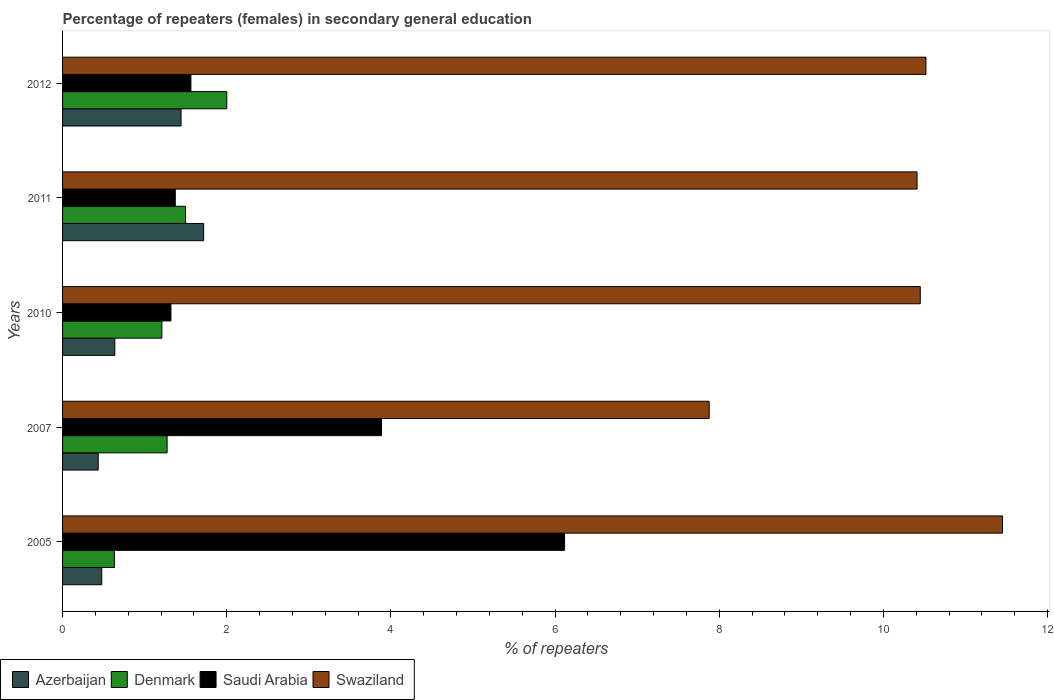How many different coloured bars are there?
Provide a short and direct response. 4. How many groups of bars are there?
Keep it short and to the point. 5. Are the number of bars on each tick of the Y-axis equal?
Ensure brevity in your answer.  Yes. How many bars are there on the 4th tick from the bottom?
Give a very brief answer. 4. In how many cases, is the number of bars for a given year not equal to the number of legend labels?
Provide a short and direct response. 0. What is the percentage of female repeaters in Swaziland in 2007?
Your answer should be compact. 7.88. Across all years, what is the maximum percentage of female repeaters in Saudi Arabia?
Ensure brevity in your answer.  6.12. Across all years, what is the minimum percentage of female repeaters in Saudi Arabia?
Keep it short and to the point. 1.32. In which year was the percentage of female repeaters in Azerbaijan maximum?
Your answer should be compact. 2011. What is the total percentage of female repeaters in Swaziland in the graph?
Offer a very short reply. 50.7. What is the difference between the percentage of female repeaters in Denmark in 2010 and that in 2011?
Give a very brief answer. -0.29. What is the difference between the percentage of female repeaters in Denmark in 2011 and the percentage of female repeaters in Swaziland in 2012?
Your answer should be very brief. -9.02. What is the average percentage of female repeaters in Denmark per year?
Offer a terse response. 1.32. In the year 2012, what is the difference between the percentage of female repeaters in Swaziland and percentage of female repeaters in Azerbaijan?
Offer a terse response. 9.07. What is the ratio of the percentage of female repeaters in Denmark in 2007 to that in 2011?
Provide a succinct answer. 0.85. Is the difference between the percentage of female repeaters in Swaziland in 2010 and 2011 greater than the difference between the percentage of female repeaters in Azerbaijan in 2010 and 2011?
Ensure brevity in your answer.  Yes. What is the difference between the highest and the second highest percentage of female repeaters in Azerbaijan?
Provide a short and direct response. 0.28. What is the difference between the highest and the lowest percentage of female repeaters in Swaziland?
Your answer should be very brief. 3.57. In how many years, is the percentage of female repeaters in Azerbaijan greater than the average percentage of female repeaters in Azerbaijan taken over all years?
Your response must be concise. 2. Is the sum of the percentage of female repeaters in Azerbaijan in 2005 and 2007 greater than the maximum percentage of female repeaters in Swaziland across all years?
Ensure brevity in your answer.  No. What does the 4th bar from the top in 2011 represents?
Provide a short and direct response. Azerbaijan. Are all the bars in the graph horizontal?
Make the answer very short. Yes. How many years are there in the graph?
Provide a short and direct response. 5. Does the graph contain any zero values?
Ensure brevity in your answer.  No. Does the graph contain grids?
Give a very brief answer. No. Where does the legend appear in the graph?
Your answer should be very brief. Bottom left. How many legend labels are there?
Keep it short and to the point. 4. What is the title of the graph?
Ensure brevity in your answer.  Percentage of repeaters (females) in secondary general education. Does "Yemen, Rep." appear as one of the legend labels in the graph?
Provide a succinct answer. No. What is the label or title of the X-axis?
Give a very brief answer. % of repeaters. What is the label or title of the Y-axis?
Make the answer very short. Years. What is the % of repeaters of Azerbaijan in 2005?
Your answer should be compact. 0.48. What is the % of repeaters in Denmark in 2005?
Ensure brevity in your answer.  0.63. What is the % of repeaters in Saudi Arabia in 2005?
Keep it short and to the point. 6.12. What is the % of repeaters in Swaziland in 2005?
Provide a short and direct response. 11.45. What is the % of repeaters in Azerbaijan in 2007?
Offer a terse response. 0.43. What is the % of repeaters in Denmark in 2007?
Ensure brevity in your answer.  1.27. What is the % of repeaters of Saudi Arabia in 2007?
Your answer should be compact. 3.89. What is the % of repeaters of Swaziland in 2007?
Your answer should be compact. 7.88. What is the % of repeaters of Azerbaijan in 2010?
Your response must be concise. 0.64. What is the % of repeaters of Denmark in 2010?
Ensure brevity in your answer.  1.21. What is the % of repeaters of Saudi Arabia in 2010?
Keep it short and to the point. 1.32. What is the % of repeaters of Swaziland in 2010?
Your response must be concise. 10.45. What is the % of repeaters in Azerbaijan in 2011?
Give a very brief answer. 1.72. What is the % of repeaters of Denmark in 2011?
Your answer should be very brief. 1.5. What is the % of repeaters of Saudi Arabia in 2011?
Give a very brief answer. 1.37. What is the % of repeaters of Swaziland in 2011?
Offer a very short reply. 10.41. What is the % of repeaters in Azerbaijan in 2012?
Your response must be concise. 1.44. What is the % of repeaters of Denmark in 2012?
Ensure brevity in your answer.  2. What is the % of repeaters in Saudi Arabia in 2012?
Provide a succinct answer. 1.56. What is the % of repeaters of Swaziland in 2012?
Offer a very short reply. 10.52. Across all years, what is the maximum % of repeaters in Azerbaijan?
Give a very brief answer. 1.72. Across all years, what is the maximum % of repeaters in Denmark?
Ensure brevity in your answer.  2. Across all years, what is the maximum % of repeaters in Saudi Arabia?
Ensure brevity in your answer.  6.12. Across all years, what is the maximum % of repeaters in Swaziland?
Ensure brevity in your answer.  11.45. Across all years, what is the minimum % of repeaters of Azerbaijan?
Give a very brief answer. 0.43. Across all years, what is the minimum % of repeaters of Denmark?
Your answer should be compact. 0.63. Across all years, what is the minimum % of repeaters in Saudi Arabia?
Provide a short and direct response. 1.32. Across all years, what is the minimum % of repeaters in Swaziland?
Ensure brevity in your answer.  7.88. What is the total % of repeaters of Azerbaijan in the graph?
Your response must be concise. 4.71. What is the total % of repeaters of Denmark in the graph?
Provide a succinct answer. 6.61. What is the total % of repeaters in Saudi Arabia in the graph?
Your answer should be very brief. 14.26. What is the total % of repeaters of Swaziland in the graph?
Provide a short and direct response. 50.7. What is the difference between the % of repeaters in Azerbaijan in 2005 and that in 2007?
Provide a short and direct response. 0.04. What is the difference between the % of repeaters in Denmark in 2005 and that in 2007?
Provide a succinct answer. -0.64. What is the difference between the % of repeaters of Saudi Arabia in 2005 and that in 2007?
Keep it short and to the point. 2.23. What is the difference between the % of repeaters of Swaziland in 2005 and that in 2007?
Provide a short and direct response. 3.57. What is the difference between the % of repeaters in Azerbaijan in 2005 and that in 2010?
Offer a terse response. -0.16. What is the difference between the % of repeaters in Denmark in 2005 and that in 2010?
Keep it short and to the point. -0.58. What is the difference between the % of repeaters of Saudi Arabia in 2005 and that in 2010?
Provide a short and direct response. 4.8. What is the difference between the % of repeaters of Swaziland in 2005 and that in 2010?
Give a very brief answer. 1. What is the difference between the % of repeaters of Azerbaijan in 2005 and that in 2011?
Ensure brevity in your answer.  -1.24. What is the difference between the % of repeaters in Denmark in 2005 and that in 2011?
Provide a short and direct response. -0.87. What is the difference between the % of repeaters of Saudi Arabia in 2005 and that in 2011?
Your response must be concise. 4.74. What is the difference between the % of repeaters of Swaziland in 2005 and that in 2011?
Keep it short and to the point. 1.04. What is the difference between the % of repeaters in Azerbaijan in 2005 and that in 2012?
Keep it short and to the point. -0.97. What is the difference between the % of repeaters of Denmark in 2005 and that in 2012?
Give a very brief answer. -1.37. What is the difference between the % of repeaters of Saudi Arabia in 2005 and that in 2012?
Your response must be concise. 4.55. What is the difference between the % of repeaters of Swaziland in 2005 and that in 2012?
Your answer should be very brief. 0.93. What is the difference between the % of repeaters in Azerbaijan in 2007 and that in 2010?
Give a very brief answer. -0.2. What is the difference between the % of repeaters in Denmark in 2007 and that in 2010?
Your response must be concise. 0.06. What is the difference between the % of repeaters in Saudi Arabia in 2007 and that in 2010?
Your response must be concise. 2.57. What is the difference between the % of repeaters in Swaziland in 2007 and that in 2010?
Your answer should be compact. -2.57. What is the difference between the % of repeaters in Azerbaijan in 2007 and that in 2011?
Keep it short and to the point. -1.28. What is the difference between the % of repeaters of Denmark in 2007 and that in 2011?
Make the answer very short. -0.22. What is the difference between the % of repeaters in Saudi Arabia in 2007 and that in 2011?
Provide a short and direct response. 2.51. What is the difference between the % of repeaters in Swaziland in 2007 and that in 2011?
Your answer should be very brief. -2.53. What is the difference between the % of repeaters of Azerbaijan in 2007 and that in 2012?
Offer a terse response. -1.01. What is the difference between the % of repeaters of Denmark in 2007 and that in 2012?
Keep it short and to the point. -0.73. What is the difference between the % of repeaters in Saudi Arabia in 2007 and that in 2012?
Offer a terse response. 2.32. What is the difference between the % of repeaters in Swaziland in 2007 and that in 2012?
Give a very brief answer. -2.64. What is the difference between the % of repeaters of Azerbaijan in 2010 and that in 2011?
Provide a succinct answer. -1.08. What is the difference between the % of repeaters in Denmark in 2010 and that in 2011?
Ensure brevity in your answer.  -0.29. What is the difference between the % of repeaters of Saudi Arabia in 2010 and that in 2011?
Give a very brief answer. -0.05. What is the difference between the % of repeaters in Swaziland in 2010 and that in 2011?
Make the answer very short. 0.04. What is the difference between the % of repeaters in Azerbaijan in 2010 and that in 2012?
Keep it short and to the point. -0.81. What is the difference between the % of repeaters in Denmark in 2010 and that in 2012?
Your answer should be compact. -0.79. What is the difference between the % of repeaters of Saudi Arabia in 2010 and that in 2012?
Your answer should be very brief. -0.24. What is the difference between the % of repeaters in Swaziland in 2010 and that in 2012?
Ensure brevity in your answer.  -0.07. What is the difference between the % of repeaters of Azerbaijan in 2011 and that in 2012?
Provide a succinct answer. 0.28. What is the difference between the % of repeaters in Denmark in 2011 and that in 2012?
Your answer should be very brief. -0.5. What is the difference between the % of repeaters of Saudi Arabia in 2011 and that in 2012?
Keep it short and to the point. -0.19. What is the difference between the % of repeaters of Swaziland in 2011 and that in 2012?
Make the answer very short. -0.11. What is the difference between the % of repeaters of Azerbaijan in 2005 and the % of repeaters of Denmark in 2007?
Provide a short and direct response. -0.8. What is the difference between the % of repeaters of Azerbaijan in 2005 and the % of repeaters of Saudi Arabia in 2007?
Keep it short and to the point. -3.41. What is the difference between the % of repeaters in Azerbaijan in 2005 and the % of repeaters in Swaziland in 2007?
Provide a short and direct response. -7.4. What is the difference between the % of repeaters of Denmark in 2005 and the % of repeaters of Saudi Arabia in 2007?
Offer a very short reply. -3.25. What is the difference between the % of repeaters in Denmark in 2005 and the % of repeaters in Swaziland in 2007?
Keep it short and to the point. -7.25. What is the difference between the % of repeaters in Saudi Arabia in 2005 and the % of repeaters in Swaziland in 2007?
Offer a very short reply. -1.76. What is the difference between the % of repeaters of Azerbaijan in 2005 and the % of repeaters of Denmark in 2010?
Provide a succinct answer. -0.73. What is the difference between the % of repeaters of Azerbaijan in 2005 and the % of repeaters of Saudi Arabia in 2010?
Offer a very short reply. -0.84. What is the difference between the % of repeaters in Azerbaijan in 2005 and the % of repeaters in Swaziland in 2010?
Keep it short and to the point. -9.97. What is the difference between the % of repeaters in Denmark in 2005 and the % of repeaters in Saudi Arabia in 2010?
Your answer should be very brief. -0.69. What is the difference between the % of repeaters in Denmark in 2005 and the % of repeaters in Swaziland in 2010?
Offer a very short reply. -9.82. What is the difference between the % of repeaters of Saudi Arabia in 2005 and the % of repeaters of Swaziland in 2010?
Give a very brief answer. -4.33. What is the difference between the % of repeaters of Azerbaijan in 2005 and the % of repeaters of Denmark in 2011?
Ensure brevity in your answer.  -1.02. What is the difference between the % of repeaters in Azerbaijan in 2005 and the % of repeaters in Saudi Arabia in 2011?
Offer a very short reply. -0.9. What is the difference between the % of repeaters in Azerbaijan in 2005 and the % of repeaters in Swaziland in 2011?
Make the answer very short. -9.93. What is the difference between the % of repeaters of Denmark in 2005 and the % of repeaters of Saudi Arabia in 2011?
Your response must be concise. -0.74. What is the difference between the % of repeaters of Denmark in 2005 and the % of repeaters of Swaziland in 2011?
Make the answer very short. -9.78. What is the difference between the % of repeaters of Saudi Arabia in 2005 and the % of repeaters of Swaziland in 2011?
Provide a succinct answer. -4.29. What is the difference between the % of repeaters of Azerbaijan in 2005 and the % of repeaters of Denmark in 2012?
Your answer should be compact. -1.52. What is the difference between the % of repeaters of Azerbaijan in 2005 and the % of repeaters of Saudi Arabia in 2012?
Provide a succinct answer. -1.09. What is the difference between the % of repeaters in Azerbaijan in 2005 and the % of repeaters in Swaziland in 2012?
Your answer should be very brief. -10.04. What is the difference between the % of repeaters in Denmark in 2005 and the % of repeaters in Saudi Arabia in 2012?
Provide a short and direct response. -0.93. What is the difference between the % of repeaters in Denmark in 2005 and the % of repeaters in Swaziland in 2012?
Provide a short and direct response. -9.89. What is the difference between the % of repeaters in Saudi Arabia in 2005 and the % of repeaters in Swaziland in 2012?
Provide a short and direct response. -4.4. What is the difference between the % of repeaters of Azerbaijan in 2007 and the % of repeaters of Denmark in 2010?
Provide a short and direct response. -0.78. What is the difference between the % of repeaters of Azerbaijan in 2007 and the % of repeaters of Saudi Arabia in 2010?
Ensure brevity in your answer.  -0.89. What is the difference between the % of repeaters of Azerbaijan in 2007 and the % of repeaters of Swaziland in 2010?
Provide a short and direct response. -10.01. What is the difference between the % of repeaters of Denmark in 2007 and the % of repeaters of Saudi Arabia in 2010?
Your answer should be very brief. -0.05. What is the difference between the % of repeaters in Denmark in 2007 and the % of repeaters in Swaziland in 2010?
Give a very brief answer. -9.17. What is the difference between the % of repeaters in Saudi Arabia in 2007 and the % of repeaters in Swaziland in 2010?
Offer a terse response. -6.56. What is the difference between the % of repeaters in Azerbaijan in 2007 and the % of repeaters in Denmark in 2011?
Provide a short and direct response. -1.06. What is the difference between the % of repeaters in Azerbaijan in 2007 and the % of repeaters in Saudi Arabia in 2011?
Provide a succinct answer. -0.94. What is the difference between the % of repeaters of Azerbaijan in 2007 and the % of repeaters of Swaziland in 2011?
Provide a succinct answer. -9.98. What is the difference between the % of repeaters in Denmark in 2007 and the % of repeaters in Saudi Arabia in 2011?
Your response must be concise. -0.1. What is the difference between the % of repeaters of Denmark in 2007 and the % of repeaters of Swaziland in 2011?
Provide a short and direct response. -9.14. What is the difference between the % of repeaters in Saudi Arabia in 2007 and the % of repeaters in Swaziland in 2011?
Your response must be concise. -6.52. What is the difference between the % of repeaters in Azerbaijan in 2007 and the % of repeaters in Denmark in 2012?
Your answer should be compact. -1.57. What is the difference between the % of repeaters of Azerbaijan in 2007 and the % of repeaters of Saudi Arabia in 2012?
Your response must be concise. -1.13. What is the difference between the % of repeaters in Azerbaijan in 2007 and the % of repeaters in Swaziland in 2012?
Give a very brief answer. -10.08. What is the difference between the % of repeaters of Denmark in 2007 and the % of repeaters of Saudi Arabia in 2012?
Offer a very short reply. -0.29. What is the difference between the % of repeaters of Denmark in 2007 and the % of repeaters of Swaziland in 2012?
Offer a very short reply. -9.24. What is the difference between the % of repeaters in Saudi Arabia in 2007 and the % of repeaters in Swaziland in 2012?
Your response must be concise. -6.63. What is the difference between the % of repeaters of Azerbaijan in 2010 and the % of repeaters of Denmark in 2011?
Provide a short and direct response. -0.86. What is the difference between the % of repeaters of Azerbaijan in 2010 and the % of repeaters of Saudi Arabia in 2011?
Give a very brief answer. -0.74. What is the difference between the % of repeaters in Azerbaijan in 2010 and the % of repeaters in Swaziland in 2011?
Make the answer very short. -9.77. What is the difference between the % of repeaters of Denmark in 2010 and the % of repeaters of Saudi Arabia in 2011?
Offer a very short reply. -0.16. What is the difference between the % of repeaters in Denmark in 2010 and the % of repeaters in Swaziland in 2011?
Provide a succinct answer. -9.2. What is the difference between the % of repeaters in Saudi Arabia in 2010 and the % of repeaters in Swaziland in 2011?
Your response must be concise. -9.09. What is the difference between the % of repeaters in Azerbaijan in 2010 and the % of repeaters in Denmark in 2012?
Your answer should be very brief. -1.36. What is the difference between the % of repeaters in Azerbaijan in 2010 and the % of repeaters in Saudi Arabia in 2012?
Your response must be concise. -0.93. What is the difference between the % of repeaters of Azerbaijan in 2010 and the % of repeaters of Swaziland in 2012?
Offer a very short reply. -9.88. What is the difference between the % of repeaters in Denmark in 2010 and the % of repeaters in Saudi Arabia in 2012?
Offer a terse response. -0.35. What is the difference between the % of repeaters of Denmark in 2010 and the % of repeaters of Swaziland in 2012?
Your answer should be very brief. -9.31. What is the difference between the % of repeaters in Saudi Arabia in 2010 and the % of repeaters in Swaziland in 2012?
Your response must be concise. -9.2. What is the difference between the % of repeaters in Azerbaijan in 2011 and the % of repeaters in Denmark in 2012?
Your response must be concise. -0.28. What is the difference between the % of repeaters of Azerbaijan in 2011 and the % of repeaters of Saudi Arabia in 2012?
Provide a succinct answer. 0.15. What is the difference between the % of repeaters of Azerbaijan in 2011 and the % of repeaters of Swaziland in 2012?
Your response must be concise. -8.8. What is the difference between the % of repeaters of Denmark in 2011 and the % of repeaters of Saudi Arabia in 2012?
Your answer should be very brief. -0.07. What is the difference between the % of repeaters in Denmark in 2011 and the % of repeaters in Swaziland in 2012?
Offer a very short reply. -9.02. What is the difference between the % of repeaters in Saudi Arabia in 2011 and the % of repeaters in Swaziland in 2012?
Provide a short and direct response. -9.14. What is the average % of repeaters in Azerbaijan per year?
Offer a terse response. 0.94. What is the average % of repeaters of Denmark per year?
Your answer should be compact. 1.32. What is the average % of repeaters in Saudi Arabia per year?
Ensure brevity in your answer.  2.85. What is the average % of repeaters of Swaziland per year?
Your response must be concise. 10.14. In the year 2005, what is the difference between the % of repeaters of Azerbaijan and % of repeaters of Denmark?
Your answer should be very brief. -0.15. In the year 2005, what is the difference between the % of repeaters in Azerbaijan and % of repeaters in Saudi Arabia?
Ensure brevity in your answer.  -5.64. In the year 2005, what is the difference between the % of repeaters of Azerbaijan and % of repeaters of Swaziland?
Offer a very short reply. -10.97. In the year 2005, what is the difference between the % of repeaters in Denmark and % of repeaters in Saudi Arabia?
Make the answer very short. -5.48. In the year 2005, what is the difference between the % of repeaters in Denmark and % of repeaters in Swaziland?
Your answer should be very brief. -10.82. In the year 2005, what is the difference between the % of repeaters of Saudi Arabia and % of repeaters of Swaziland?
Provide a succinct answer. -5.33. In the year 2007, what is the difference between the % of repeaters of Azerbaijan and % of repeaters of Denmark?
Your answer should be compact. -0.84. In the year 2007, what is the difference between the % of repeaters in Azerbaijan and % of repeaters in Saudi Arabia?
Offer a very short reply. -3.45. In the year 2007, what is the difference between the % of repeaters in Azerbaijan and % of repeaters in Swaziland?
Provide a short and direct response. -7.44. In the year 2007, what is the difference between the % of repeaters of Denmark and % of repeaters of Saudi Arabia?
Give a very brief answer. -2.61. In the year 2007, what is the difference between the % of repeaters of Denmark and % of repeaters of Swaziland?
Your answer should be very brief. -6.6. In the year 2007, what is the difference between the % of repeaters of Saudi Arabia and % of repeaters of Swaziland?
Give a very brief answer. -3.99. In the year 2010, what is the difference between the % of repeaters in Azerbaijan and % of repeaters in Denmark?
Your response must be concise. -0.57. In the year 2010, what is the difference between the % of repeaters of Azerbaijan and % of repeaters of Saudi Arabia?
Offer a very short reply. -0.68. In the year 2010, what is the difference between the % of repeaters in Azerbaijan and % of repeaters in Swaziland?
Ensure brevity in your answer.  -9.81. In the year 2010, what is the difference between the % of repeaters in Denmark and % of repeaters in Saudi Arabia?
Your response must be concise. -0.11. In the year 2010, what is the difference between the % of repeaters in Denmark and % of repeaters in Swaziland?
Your answer should be compact. -9.24. In the year 2010, what is the difference between the % of repeaters in Saudi Arabia and % of repeaters in Swaziland?
Your answer should be compact. -9.13. In the year 2011, what is the difference between the % of repeaters of Azerbaijan and % of repeaters of Denmark?
Your answer should be compact. 0.22. In the year 2011, what is the difference between the % of repeaters in Azerbaijan and % of repeaters in Saudi Arabia?
Offer a terse response. 0.35. In the year 2011, what is the difference between the % of repeaters in Azerbaijan and % of repeaters in Swaziland?
Provide a succinct answer. -8.69. In the year 2011, what is the difference between the % of repeaters of Denmark and % of repeaters of Saudi Arabia?
Provide a short and direct response. 0.13. In the year 2011, what is the difference between the % of repeaters in Denmark and % of repeaters in Swaziland?
Your answer should be compact. -8.91. In the year 2011, what is the difference between the % of repeaters in Saudi Arabia and % of repeaters in Swaziland?
Your answer should be compact. -9.04. In the year 2012, what is the difference between the % of repeaters of Azerbaijan and % of repeaters of Denmark?
Ensure brevity in your answer.  -0.56. In the year 2012, what is the difference between the % of repeaters in Azerbaijan and % of repeaters in Saudi Arabia?
Your answer should be very brief. -0.12. In the year 2012, what is the difference between the % of repeaters of Azerbaijan and % of repeaters of Swaziland?
Offer a terse response. -9.07. In the year 2012, what is the difference between the % of repeaters of Denmark and % of repeaters of Saudi Arabia?
Make the answer very short. 0.44. In the year 2012, what is the difference between the % of repeaters in Denmark and % of repeaters in Swaziland?
Offer a terse response. -8.52. In the year 2012, what is the difference between the % of repeaters in Saudi Arabia and % of repeaters in Swaziland?
Your response must be concise. -8.95. What is the ratio of the % of repeaters of Azerbaijan in 2005 to that in 2007?
Keep it short and to the point. 1.1. What is the ratio of the % of repeaters of Denmark in 2005 to that in 2007?
Your answer should be compact. 0.5. What is the ratio of the % of repeaters in Saudi Arabia in 2005 to that in 2007?
Provide a succinct answer. 1.57. What is the ratio of the % of repeaters of Swaziland in 2005 to that in 2007?
Make the answer very short. 1.45. What is the ratio of the % of repeaters of Azerbaijan in 2005 to that in 2010?
Provide a short and direct response. 0.75. What is the ratio of the % of repeaters of Denmark in 2005 to that in 2010?
Your answer should be compact. 0.52. What is the ratio of the % of repeaters in Saudi Arabia in 2005 to that in 2010?
Your answer should be compact. 4.63. What is the ratio of the % of repeaters of Swaziland in 2005 to that in 2010?
Your answer should be very brief. 1.1. What is the ratio of the % of repeaters in Azerbaijan in 2005 to that in 2011?
Your answer should be very brief. 0.28. What is the ratio of the % of repeaters in Denmark in 2005 to that in 2011?
Keep it short and to the point. 0.42. What is the ratio of the % of repeaters of Saudi Arabia in 2005 to that in 2011?
Offer a terse response. 4.45. What is the ratio of the % of repeaters in Swaziland in 2005 to that in 2011?
Offer a very short reply. 1.1. What is the ratio of the % of repeaters of Azerbaijan in 2005 to that in 2012?
Your answer should be compact. 0.33. What is the ratio of the % of repeaters of Denmark in 2005 to that in 2012?
Provide a succinct answer. 0.32. What is the ratio of the % of repeaters in Saudi Arabia in 2005 to that in 2012?
Provide a short and direct response. 3.91. What is the ratio of the % of repeaters in Swaziland in 2005 to that in 2012?
Provide a succinct answer. 1.09. What is the ratio of the % of repeaters in Azerbaijan in 2007 to that in 2010?
Keep it short and to the point. 0.68. What is the ratio of the % of repeaters of Denmark in 2007 to that in 2010?
Offer a very short reply. 1.05. What is the ratio of the % of repeaters in Saudi Arabia in 2007 to that in 2010?
Your answer should be very brief. 2.94. What is the ratio of the % of repeaters in Swaziland in 2007 to that in 2010?
Make the answer very short. 0.75. What is the ratio of the % of repeaters of Azerbaijan in 2007 to that in 2011?
Provide a short and direct response. 0.25. What is the ratio of the % of repeaters in Denmark in 2007 to that in 2011?
Offer a very short reply. 0.85. What is the ratio of the % of repeaters of Saudi Arabia in 2007 to that in 2011?
Your answer should be very brief. 2.83. What is the ratio of the % of repeaters of Swaziland in 2007 to that in 2011?
Offer a terse response. 0.76. What is the ratio of the % of repeaters of Azerbaijan in 2007 to that in 2012?
Provide a short and direct response. 0.3. What is the ratio of the % of repeaters in Denmark in 2007 to that in 2012?
Ensure brevity in your answer.  0.64. What is the ratio of the % of repeaters in Saudi Arabia in 2007 to that in 2012?
Your answer should be compact. 2.49. What is the ratio of the % of repeaters in Swaziland in 2007 to that in 2012?
Keep it short and to the point. 0.75. What is the ratio of the % of repeaters in Azerbaijan in 2010 to that in 2011?
Keep it short and to the point. 0.37. What is the ratio of the % of repeaters of Denmark in 2010 to that in 2011?
Give a very brief answer. 0.81. What is the ratio of the % of repeaters in Saudi Arabia in 2010 to that in 2011?
Offer a terse response. 0.96. What is the ratio of the % of repeaters of Azerbaijan in 2010 to that in 2012?
Your answer should be very brief. 0.44. What is the ratio of the % of repeaters in Denmark in 2010 to that in 2012?
Ensure brevity in your answer.  0.6. What is the ratio of the % of repeaters of Saudi Arabia in 2010 to that in 2012?
Your response must be concise. 0.84. What is the ratio of the % of repeaters in Swaziland in 2010 to that in 2012?
Make the answer very short. 0.99. What is the ratio of the % of repeaters in Azerbaijan in 2011 to that in 2012?
Your response must be concise. 1.19. What is the ratio of the % of repeaters in Denmark in 2011 to that in 2012?
Give a very brief answer. 0.75. What is the ratio of the % of repeaters in Saudi Arabia in 2011 to that in 2012?
Your answer should be compact. 0.88. What is the ratio of the % of repeaters of Swaziland in 2011 to that in 2012?
Provide a short and direct response. 0.99. What is the difference between the highest and the second highest % of repeaters in Azerbaijan?
Your answer should be very brief. 0.28. What is the difference between the highest and the second highest % of repeaters of Denmark?
Your response must be concise. 0.5. What is the difference between the highest and the second highest % of repeaters of Saudi Arabia?
Your response must be concise. 2.23. What is the difference between the highest and the second highest % of repeaters of Swaziland?
Provide a short and direct response. 0.93. What is the difference between the highest and the lowest % of repeaters of Azerbaijan?
Provide a succinct answer. 1.28. What is the difference between the highest and the lowest % of repeaters in Denmark?
Your answer should be very brief. 1.37. What is the difference between the highest and the lowest % of repeaters of Saudi Arabia?
Make the answer very short. 4.8. What is the difference between the highest and the lowest % of repeaters of Swaziland?
Offer a very short reply. 3.57. 